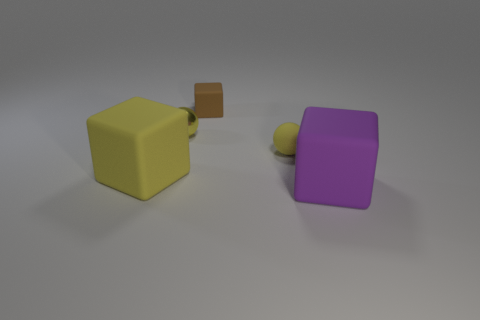Is the color of the shiny thing the same as the small matte sphere?
Give a very brief answer. Yes. What shape is the brown rubber thing that is the same size as the shiny thing?
Make the answer very short. Cube. The purple block is what size?
Your answer should be very brief. Large. Is the size of the ball left of the brown matte block the same as the brown rubber thing on the left side of the large purple rubber object?
Keep it short and to the point. Yes. There is a ball that is left of the tiny brown object behind the yellow rubber sphere; what is its color?
Make the answer very short. Yellow. What is the material of the block that is the same size as the rubber ball?
Your response must be concise. Rubber. How many matte objects are big purple blocks or yellow things?
Your response must be concise. 3. There is a rubber object that is both in front of the small yellow matte thing and right of the tiny brown cube; what is its color?
Your answer should be very brief. Purple. What number of brown matte things are in front of the purple matte block?
Your answer should be very brief. 0. What is the purple block made of?
Ensure brevity in your answer.  Rubber. 